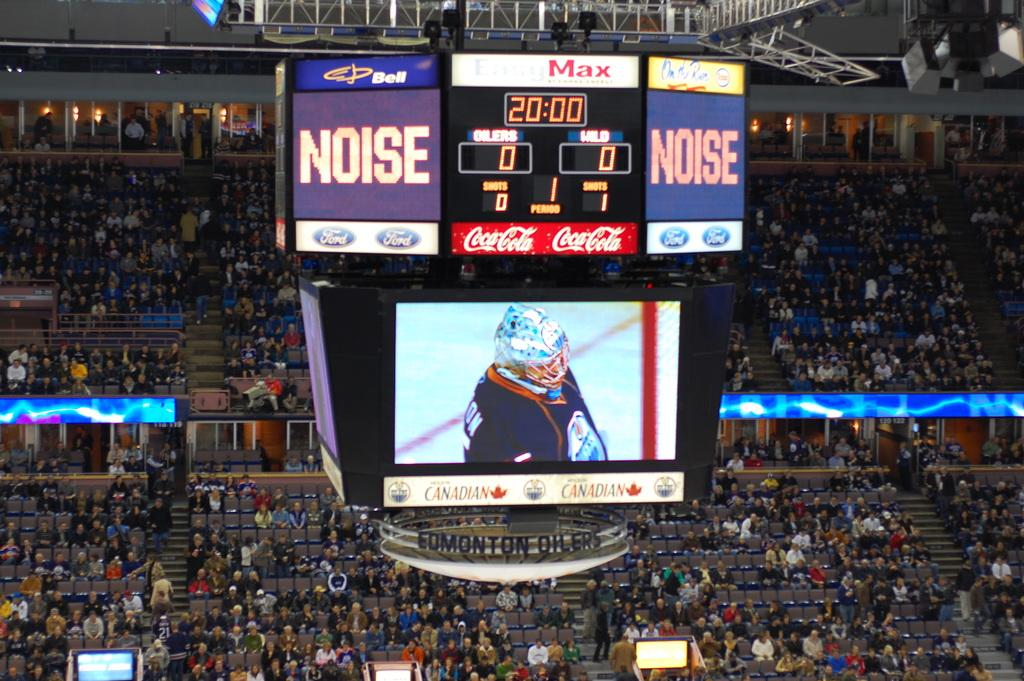Provide a one-sentence caption for the provided image. People sitting in packed bleachers at a Noise hockey game. 